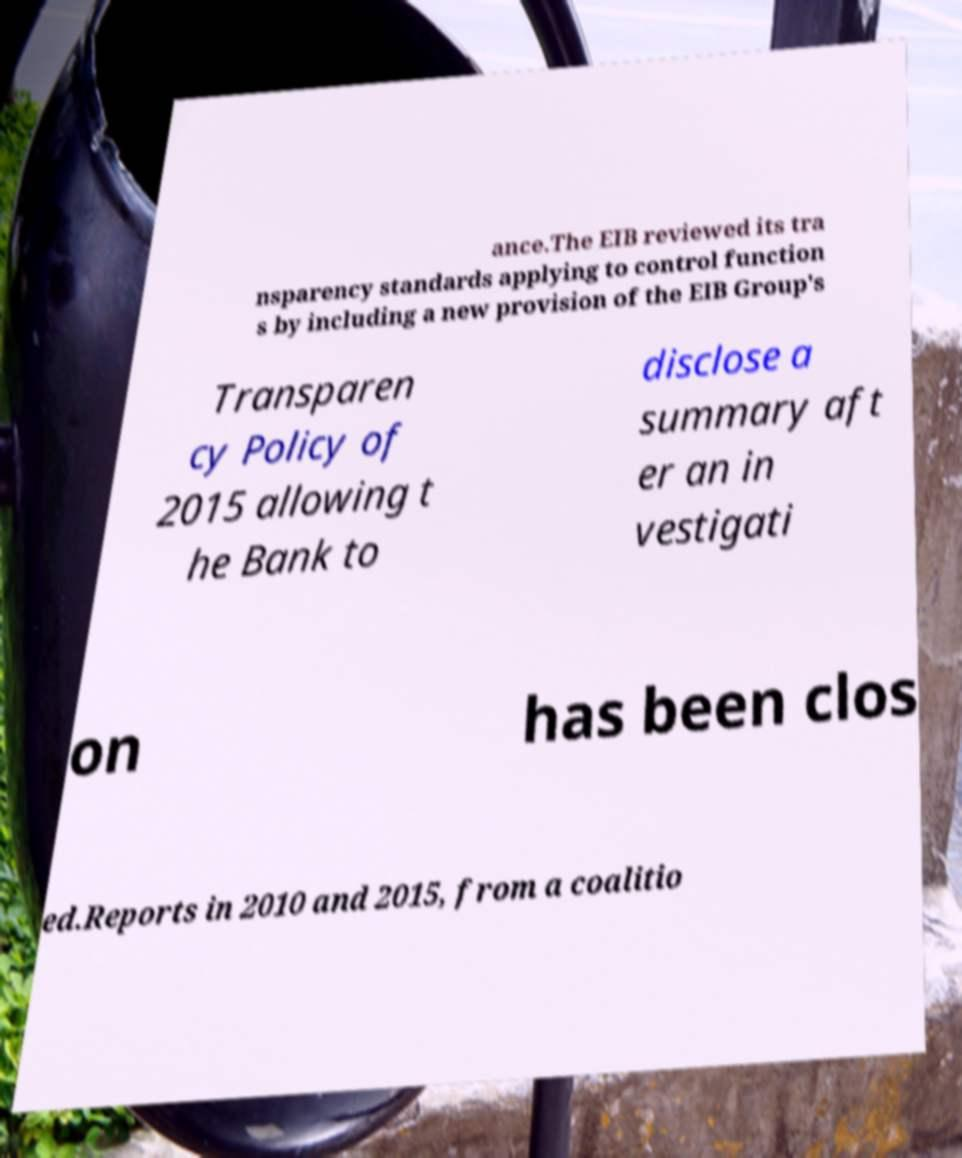Could you extract and type out the text from this image? ance.The EIB reviewed its tra nsparency standards applying to control function s by including a new provision of the EIB Group's Transparen cy Policy of 2015 allowing t he Bank to disclose a summary aft er an in vestigati on has been clos ed.Reports in 2010 and 2015, from a coalitio 